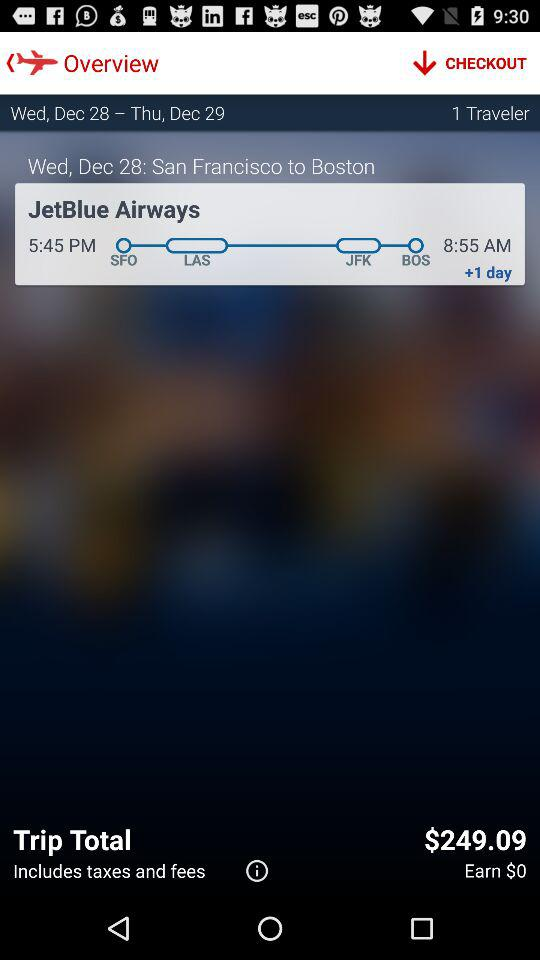How many days is the trip?
Answer the question using a single word or phrase. 2 days 